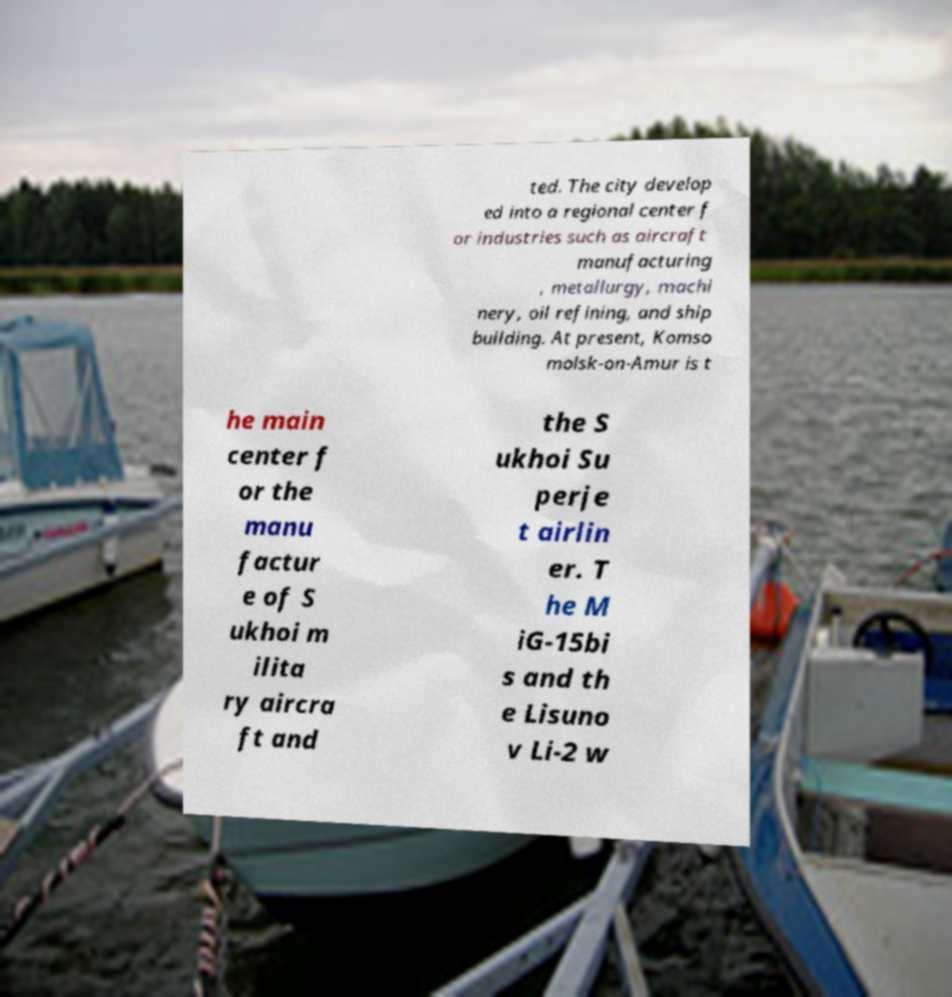Could you extract and type out the text from this image? ted. The city develop ed into a regional center f or industries such as aircraft manufacturing , metallurgy, machi nery, oil refining, and ship building. At present, Komso molsk-on-Amur is t he main center f or the manu factur e of S ukhoi m ilita ry aircra ft and the S ukhoi Su perje t airlin er. T he M iG-15bi s and th e Lisuno v Li-2 w 